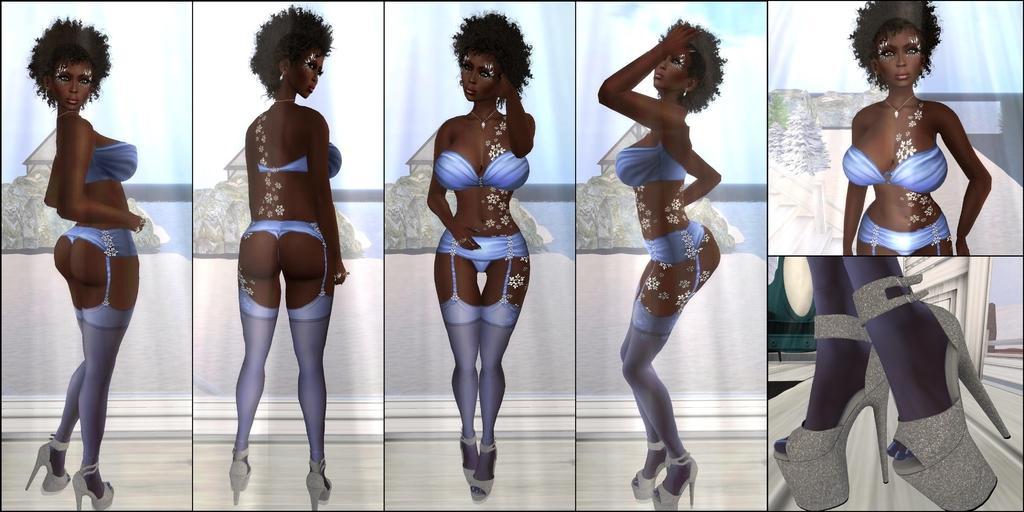How would you summarize this image in a sentence or two? This is a collage image. There are depictions of a woman. 